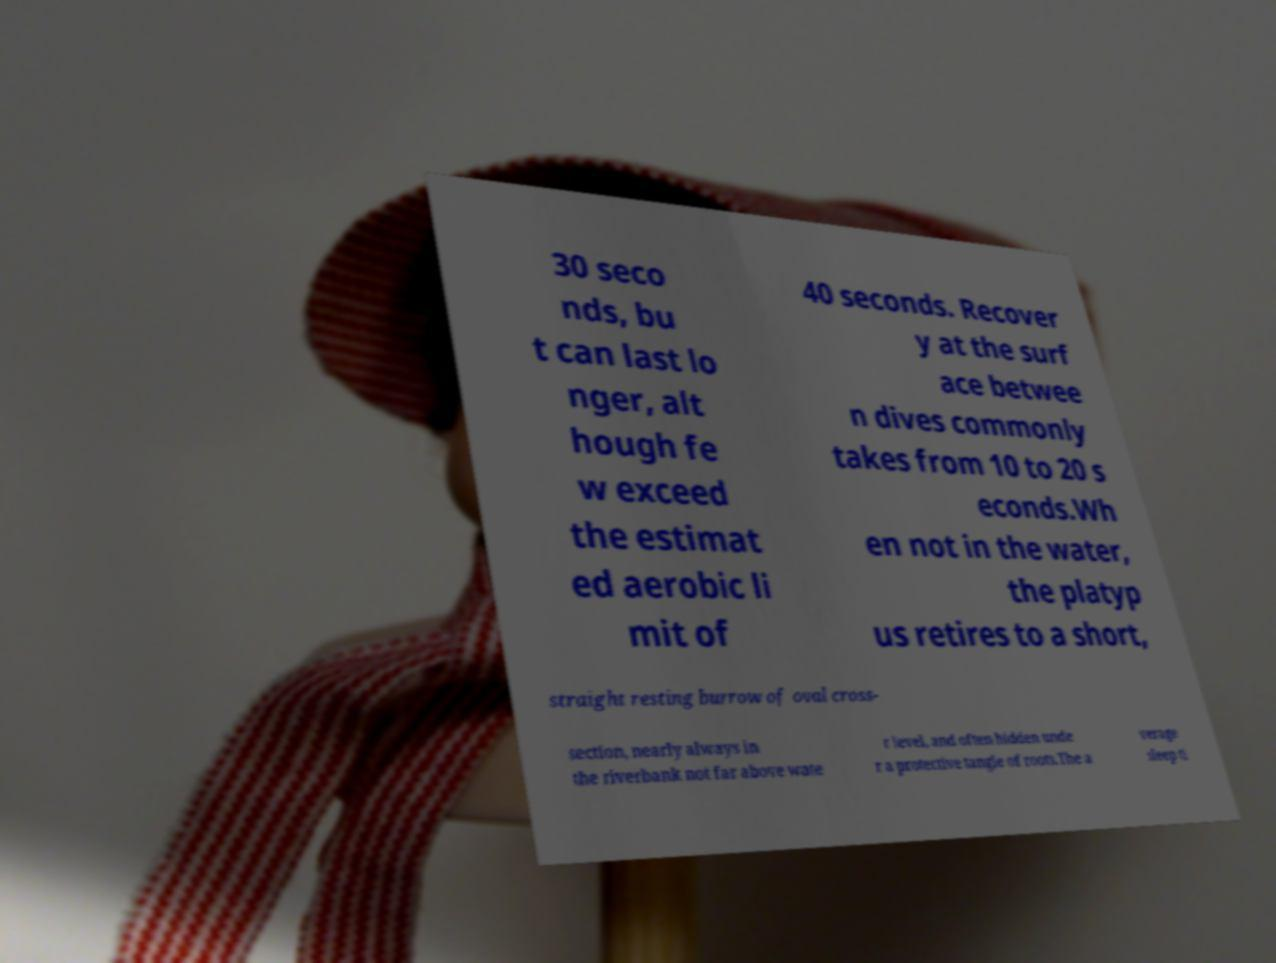Please identify and transcribe the text found in this image. 30 seco nds, bu t can last lo nger, alt hough fe w exceed the estimat ed aerobic li mit of 40 seconds. Recover y at the surf ace betwee n dives commonly takes from 10 to 20 s econds.Wh en not in the water, the platyp us retires to a short, straight resting burrow of oval cross- section, nearly always in the riverbank not far above wate r level, and often hidden unde r a protective tangle of roots.The a verage sleep ti 